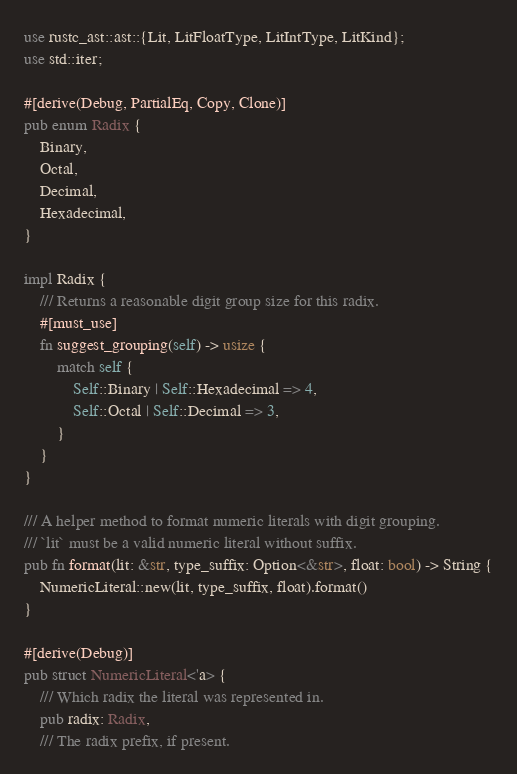<code> <loc_0><loc_0><loc_500><loc_500><_Rust_>use rustc_ast::ast::{Lit, LitFloatType, LitIntType, LitKind};
use std::iter;

#[derive(Debug, PartialEq, Copy, Clone)]
pub enum Radix {
    Binary,
    Octal,
    Decimal,
    Hexadecimal,
}

impl Radix {
    /// Returns a reasonable digit group size for this radix.
    #[must_use]
    fn suggest_grouping(self) -> usize {
        match self {
            Self::Binary | Self::Hexadecimal => 4,
            Self::Octal | Self::Decimal => 3,
        }
    }
}

/// A helper method to format numeric literals with digit grouping.
/// `lit` must be a valid numeric literal without suffix.
pub fn format(lit: &str, type_suffix: Option<&str>, float: bool) -> String {
    NumericLiteral::new(lit, type_suffix, float).format()
}

#[derive(Debug)]
pub struct NumericLiteral<'a> {
    /// Which radix the literal was represented in.
    pub radix: Radix,
    /// The radix prefix, if present.</code> 